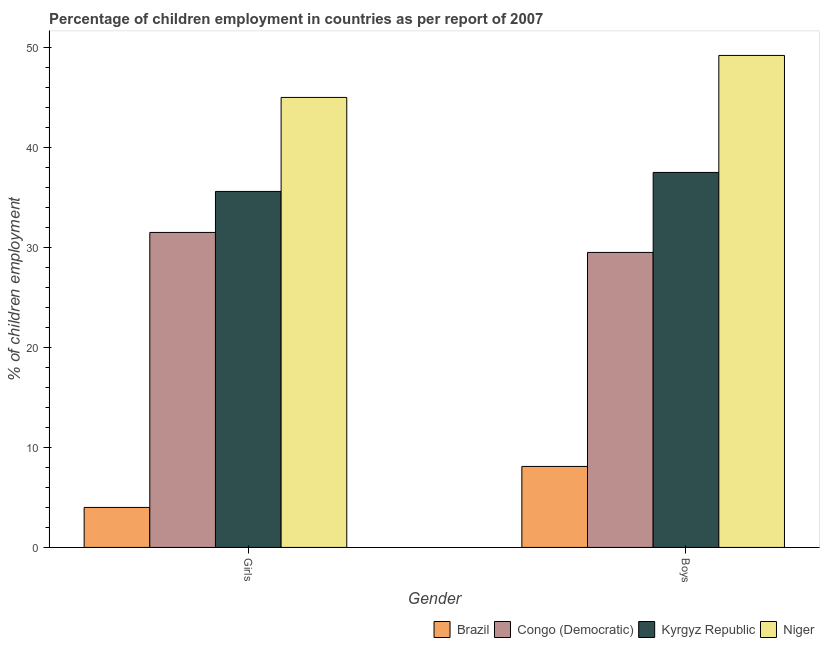How many different coloured bars are there?
Your answer should be very brief. 4. What is the label of the 1st group of bars from the left?
Make the answer very short. Girls. What is the percentage of employed boys in Brazil?
Offer a terse response. 8.1. Across all countries, what is the maximum percentage of employed boys?
Ensure brevity in your answer.  49.2. In which country was the percentage of employed boys maximum?
Provide a succinct answer. Niger. In which country was the percentage of employed girls minimum?
Provide a short and direct response. Brazil. What is the total percentage of employed boys in the graph?
Offer a terse response. 124.3. What is the difference between the percentage of employed girls in Kyrgyz Republic and that in Congo (Democratic)?
Provide a succinct answer. 4.1. What is the difference between the percentage of employed girls in Kyrgyz Republic and the percentage of employed boys in Niger?
Offer a very short reply. -13.6. What is the average percentage of employed boys per country?
Offer a terse response. 31.07. What is the ratio of the percentage of employed boys in Kyrgyz Republic to that in Niger?
Your answer should be compact. 0.76. In how many countries, is the percentage of employed girls greater than the average percentage of employed girls taken over all countries?
Your answer should be very brief. 3. What does the 2nd bar from the left in Girls represents?
Give a very brief answer. Congo (Democratic). What does the 4th bar from the right in Boys represents?
Make the answer very short. Brazil. How many bars are there?
Offer a very short reply. 8. How many legend labels are there?
Your response must be concise. 4. How are the legend labels stacked?
Offer a very short reply. Horizontal. What is the title of the graph?
Your response must be concise. Percentage of children employment in countries as per report of 2007. Does "Dominica" appear as one of the legend labels in the graph?
Your response must be concise. No. What is the label or title of the X-axis?
Your answer should be very brief. Gender. What is the label or title of the Y-axis?
Your answer should be very brief. % of children employment. What is the % of children employment of Congo (Democratic) in Girls?
Keep it short and to the point. 31.5. What is the % of children employment in Kyrgyz Republic in Girls?
Ensure brevity in your answer.  35.6. What is the % of children employment of Brazil in Boys?
Make the answer very short. 8.1. What is the % of children employment in Congo (Democratic) in Boys?
Your answer should be very brief. 29.5. What is the % of children employment of Kyrgyz Republic in Boys?
Give a very brief answer. 37.5. What is the % of children employment of Niger in Boys?
Your answer should be very brief. 49.2. Across all Gender, what is the maximum % of children employment in Brazil?
Offer a very short reply. 8.1. Across all Gender, what is the maximum % of children employment in Congo (Democratic)?
Your answer should be compact. 31.5. Across all Gender, what is the maximum % of children employment in Kyrgyz Republic?
Offer a very short reply. 37.5. Across all Gender, what is the maximum % of children employment in Niger?
Provide a succinct answer. 49.2. Across all Gender, what is the minimum % of children employment in Brazil?
Offer a very short reply. 4. Across all Gender, what is the minimum % of children employment in Congo (Democratic)?
Your answer should be very brief. 29.5. Across all Gender, what is the minimum % of children employment of Kyrgyz Republic?
Ensure brevity in your answer.  35.6. Across all Gender, what is the minimum % of children employment in Niger?
Offer a very short reply. 45. What is the total % of children employment in Brazil in the graph?
Keep it short and to the point. 12.1. What is the total % of children employment of Congo (Democratic) in the graph?
Your answer should be compact. 61. What is the total % of children employment of Kyrgyz Republic in the graph?
Provide a short and direct response. 73.1. What is the total % of children employment in Niger in the graph?
Your answer should be very brief. 94.2. What is the difference between the % of children employment of Congo (Democratic) in Girls and that in Boys?
Your answer should be very brief. 2. What is the difference between the % of children employment of Niger in Girls and that in Boys?
Offer a very short reply. -4.2. What is the difference between the % of children employment of Brazil in Girls and the % of children employment of Congo (Democratic) in Boys?
Provide a succinct answer. -25.5. What is the difference between the % of children employment in Brazil in Girls and the % of children employment in Kyrgyz Republic in Boys?
Your response must be concise. -33.5. What is the difference between the % of children employment in Brazil in Girls and the % of children employment in Niger in Boys?
Keep it short and to the point. -45.2. What is the difference between the % of children employment in Congo (Democratic) in Girls and the % of children employment in Niger in Boys?
Your response must be concise. -17.7. What is the difference between the % of children employment of Kyrgyz Republic in Girls and the % of children employment of Niger in Boys?
Offer a very short reply. -13.6. What is the average % of children employment of Brazil per Gender?
Ensure brevity in your answer.  6.05. What is the average % of children employment in Congo (Democratic) per Gender?
Your answer should be very brief. 30.5. What is the average % of children employment in Kyrgyz Republic per Gender?
Provide a succinct answer. 36.55. What is the average % of children employment of Niger per Gender?
Your answer should be compact. 47.1. What is the difference between the % of children employment in Brazil and % of children employment in Congo (Democratic) in Girls?
Provide a short and direct response. -27.5. What is the difference between the % of children employment of Brazil and % of children employment of Kyrgyz Republic in Girls?
Your answer should be very brief. -31.6. What is the difference between the % of children employment of Brazil and % of children employment of Niger in Girls?
Your answer should be very brief. -41. What is the difference between the % of children employment in Congo (Democratic) and % of children employment in Kyrgyz Republic in Girls?
Offer a terse response. -4.1. What is the difference between the % of children employment in Kyrgyz Republic and % of children employment in Niger in Girls?
Ensure brevity in your answer.  -9.4. What is the difference between the % of children employment in Brazil and % of children employment in Congo (Democratic) in Boys?
Your answer should be compact. -21.4. What is the difference between the % of children employment of Brazil and % of children employment of Kyrgyz Republic in Boys?
Keep it short and to the point. -29.4. What is the difference between the % of children employment in Brazil and % of children employment in Niger in Boys?
Provide a short and direct response. -41.1. What is the difference between the % of children employment in Congo (Democratic) and % of children employment in Kyrgyz Republic in Boys?
Provide a short and direct response. -8. What is the difference between the % of children employment of Congo (Democratic) and % of children employment of Niger in Boys?
Keep it short and to the point. -19.7. What is the ratio of the % of children employment of Brazil in Girls to that in Boys?
Offer a very short reply. 0.49. What is the ratio of the % of children employment in Congo (Democratic) in Girls to that in Boys?
Offer a very short reply. 1.07. What is the ratio of the % of children employment in Kyrgyz Republic in Girls to that in Boys?
Your answer should be compact. 0.95. What is the ratio of the % of children employment in Niger in Girls to that in Boys?
Your response must be concise. 0.91. What is the difference between the highest and the second highest % of children employment in Brazil?
Your response must be concise. 4.1. What is the difference between the highest and the second highest % of children employment in Niger?
Make the answer very short. 4.2. What is the difference between the highest and the lowest % of children employment in Brazil?
Your response must be concise. 4.1. What is the difference between the highest and the lowest % of children employment in Congo (Democratic)?
Your answer should be compact. 2. What is the difference between the highest and the lowest % of children employment of Kyrgyz Republic?
Offer a terse response. 1.9. What is the difference between the highest and the lowest % of children employment of Niger?
Keep it short and to the point. 4.2. 